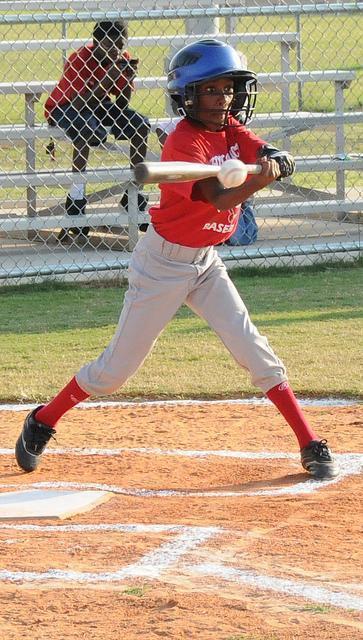What team wears similar socks to the boy in the foreground?
Make your selection from the four choices given to correctly answer the question.
Options: Mets, jets, red sox, white sox. Red sox. 